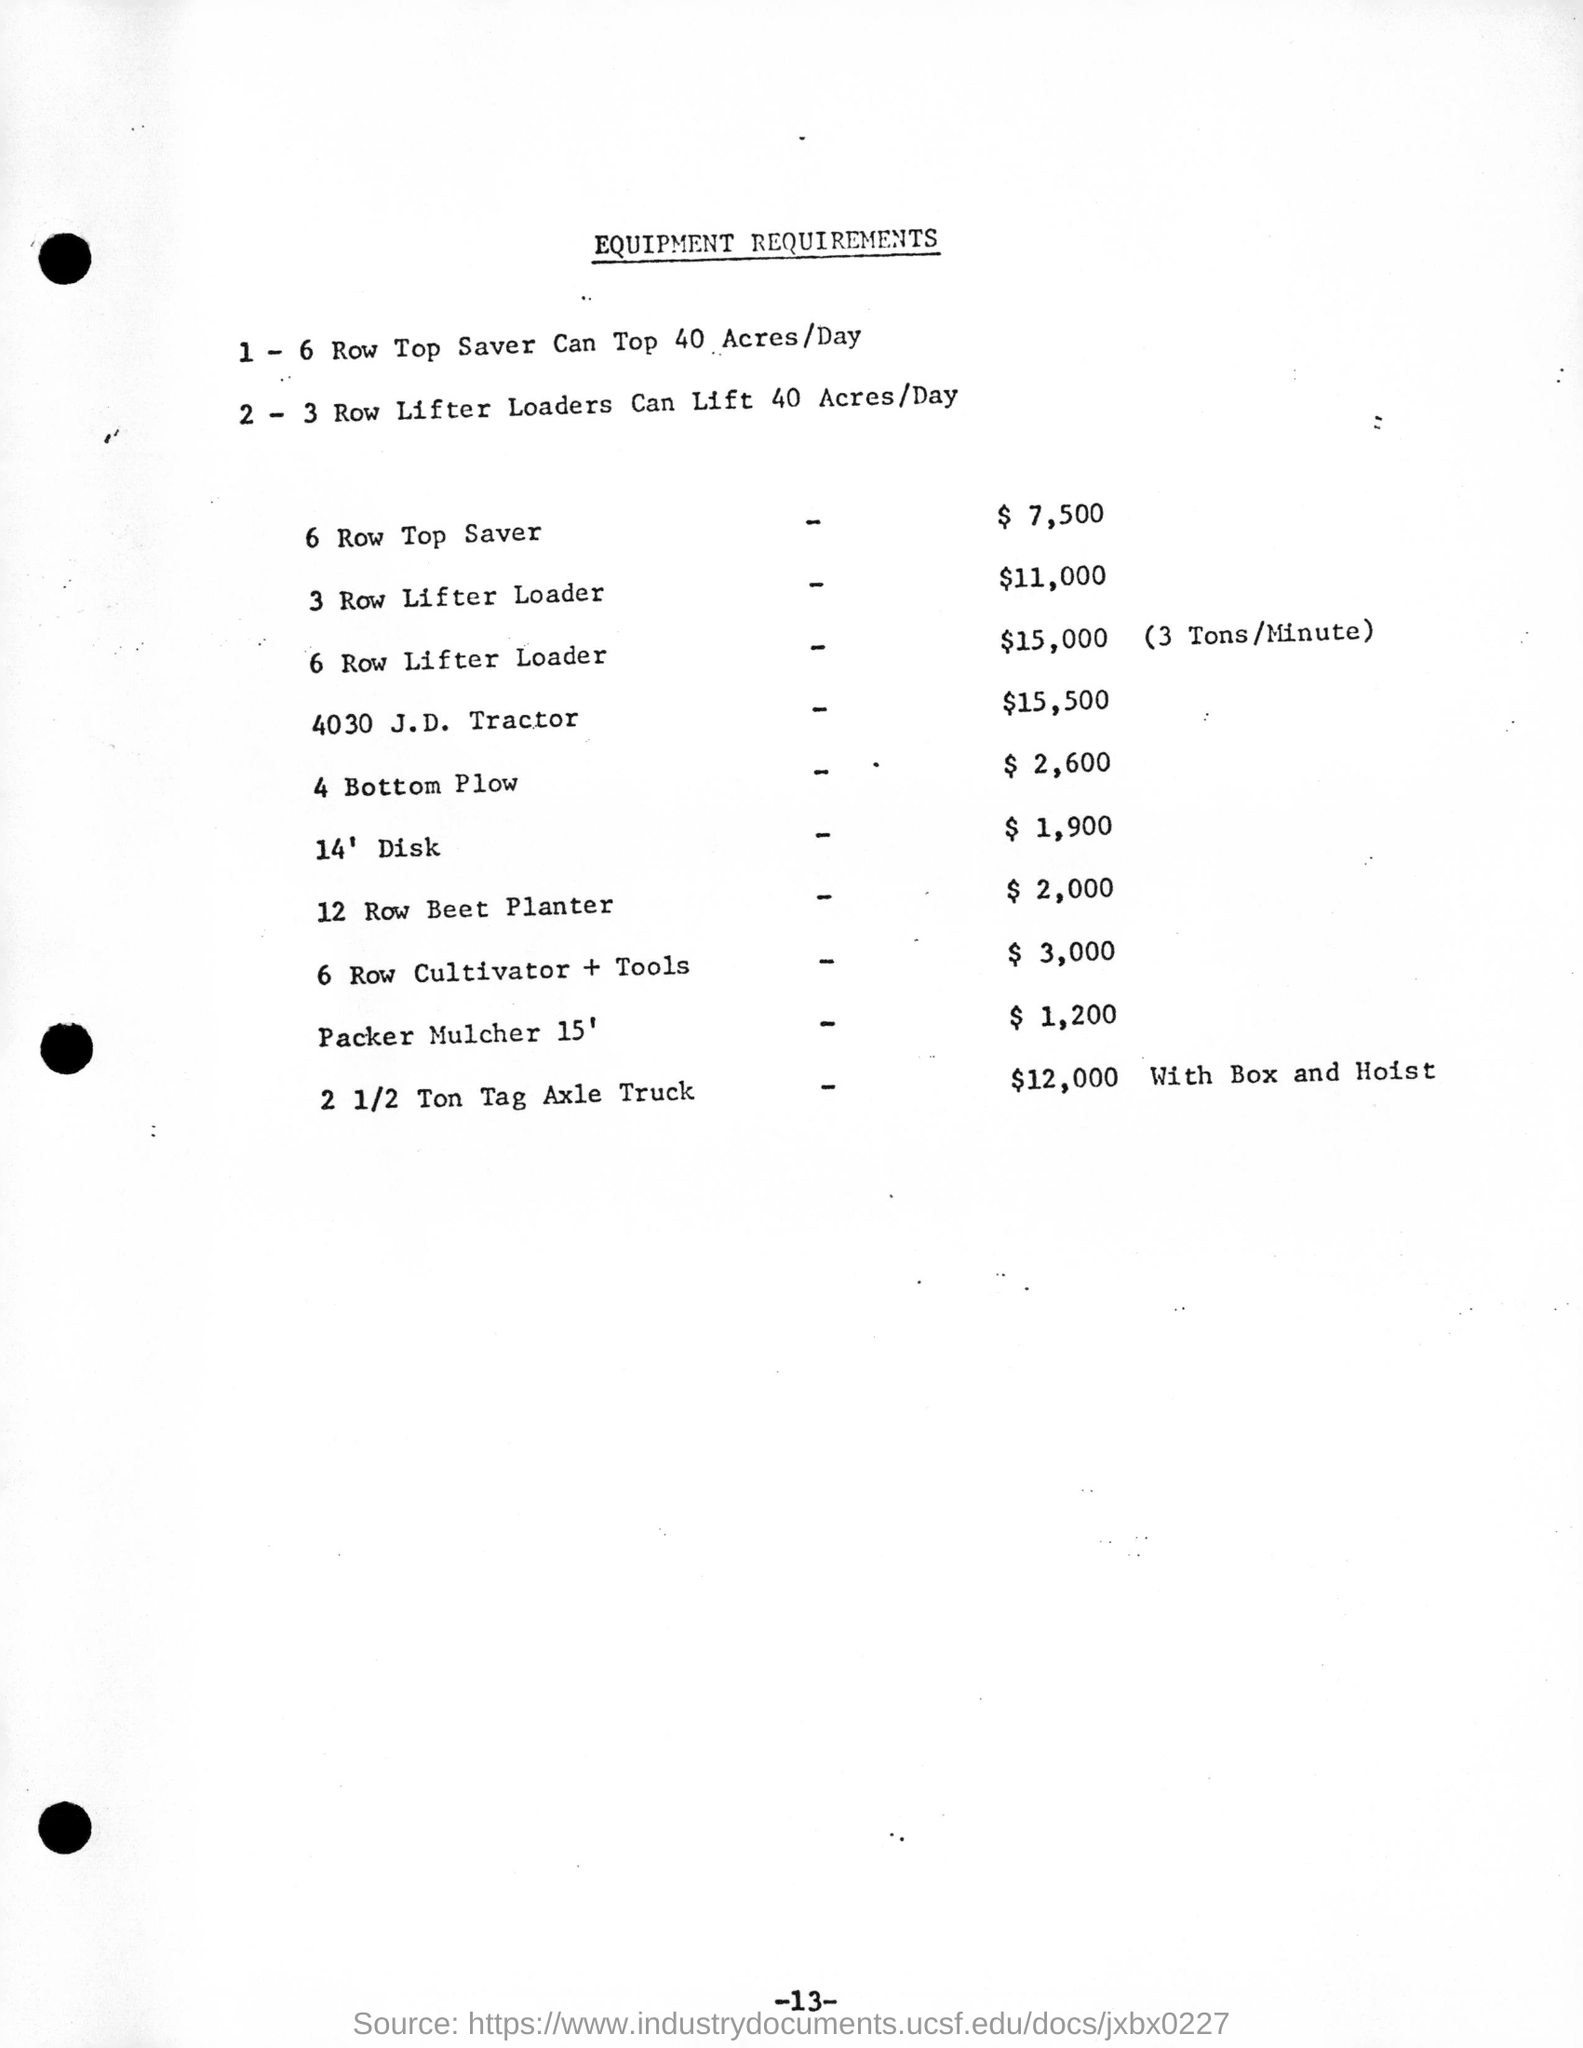How many can 2-3 row lifter loaders can lift per day ?
Provide a succinct answer. 40 Acres/Day. What is the cost of 4030 j.d. tractor ?
Keep it short and to the point. $15,500. Which is the equipment that costs $7,500 ?
Your response must be concise. 6 row top saver. What is the cost of 12 row beet planter?
Provide a succinct answer. $ 2,000. What is the cost of 4 bottom plow?
Ensure brevity in your answer.  $ 2,600. How much tons can the 6 row lifter loader can handle in a minute?
Your answer should be compact. 3 tons/minute. 